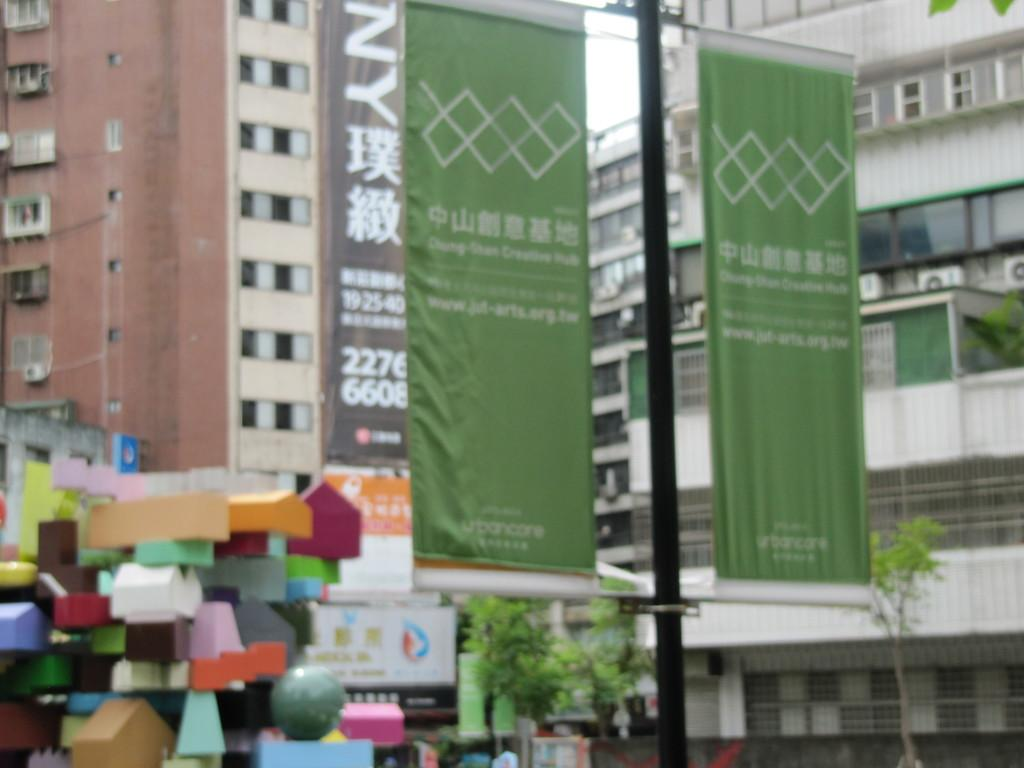What type of structures can be seen in the image? There are buildings in the image. What is attached to the pole in the image? There is a pole with banners in the image. What type of vegetation is visible in the image? There are trees visible in the image. What other objects can be seen in the image besides buildings and trees? There are other objects in the image. Where is the hydrant located in the image? There is no hydrant present in the image. What type of carriage is being pulled by horses in the image? There is no carriage or horses present in the image. 